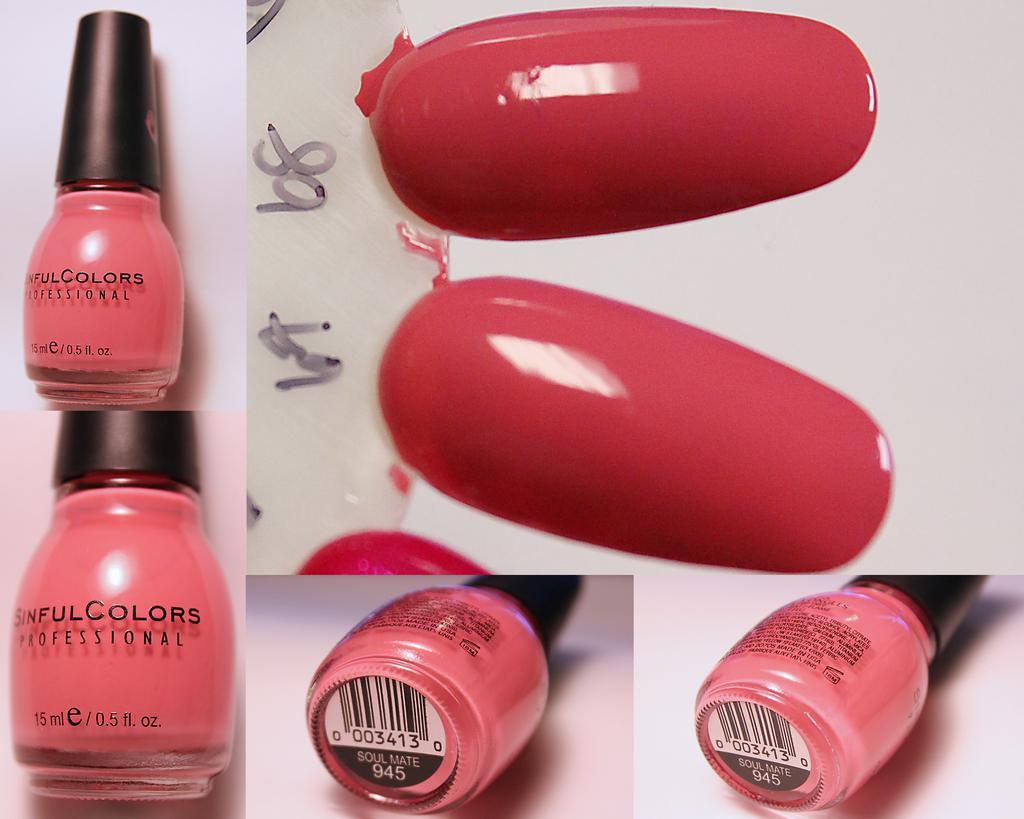Describe this image in one or two sentences. In this image I can see the collage picture in which I can see few nail polish bottles which are pink and black in color and few plastic nails which are pink in color. I can see the white colored background. 